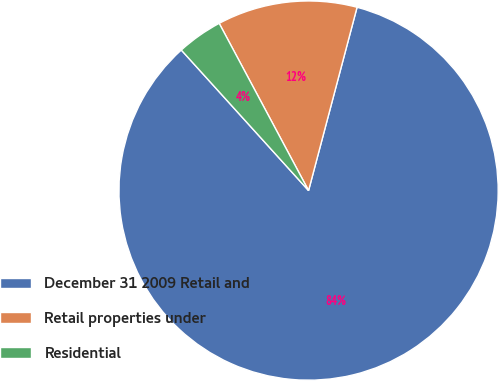Convert chart to OTSL. <chart><loc_0><loc_0><loc_500><loc_500><pie_chart><fcel>December 31 2009 Retail and<fcel>Retail properties under<fcel>Residential<nl><fcel>84.18%<fcel>11.93%<fcel>3.9%<nl></chart> 